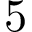Convert formula to latex. <formula><loc_0><loc_0><loc_500><loc_500>5</formula> 